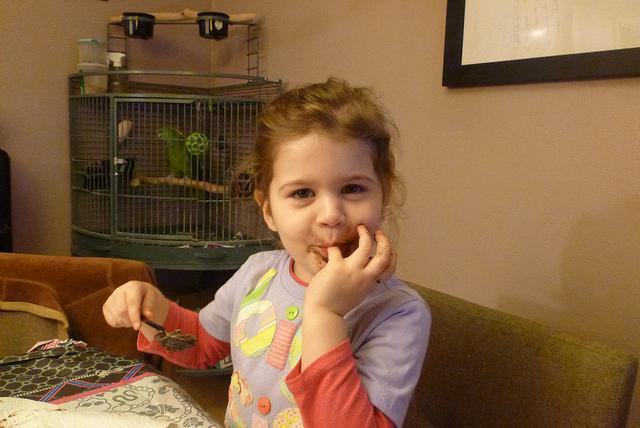How many people are awake?
Give a very brief answer. 1. How many chairs are there?
Give a very brief answer. 2. 